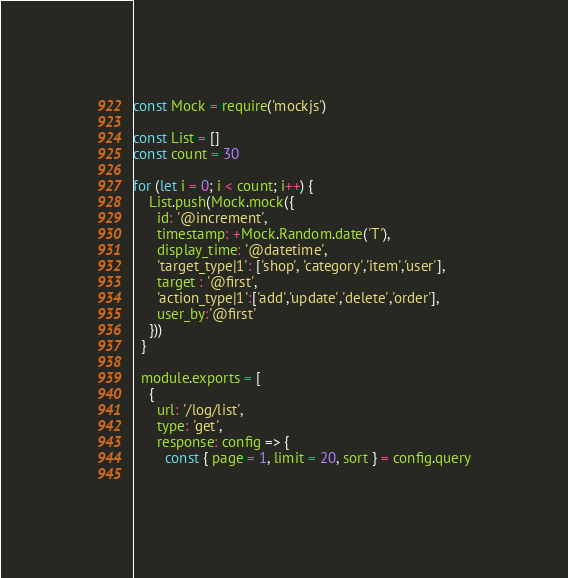<code> <loc_0><loc_0><loc_500><loc_500><_JavaScript_>const Mock = require('mockjs')

const List = []
const count = 30

for (let i = 0; i < count; i++) {
    List.push(Mock.mock({
      id: '@increment',
      timestamp: +Mock.Random.date('T'),
      display_time: '@datetime',
      'target_type|1': ['shop', 'category','item','user'],
      target : '@first',
      'action_type|1':['add','update','delete','order'],
      user_by:'@first'
    }))
  }

  module.exports = [
    {
      url: '/log/list',
      type: 'get',
      response: config => {
        const { page = 1, limit = 20, sort } = config.query
  </code> 